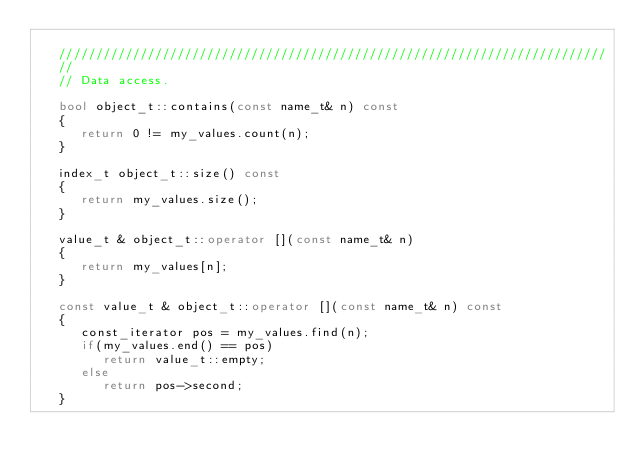<code> <loc_0><loc_0><loc_500><loc_500><_C++_>
   //////////////////////////////////////////////////////////////////////////
   //
   // Data access.

   bool object_t::contains(const name_t& n) const
   {
      return 0 != my_values.count(n);
   }

   index_t object_t::size() const
   {
      return my_values.size();
   }

   value_t & object_t::operator [](const name_t& n)
   {
      return my_values[n];
   }

   const value_t & object_t::operator [](const name_t& n) const
   {
      const_iterator pos = my_values.find(n);
      if(my_values.end() == pos)
         return value_t::empty;
      else
         return pos->second;
   }
</code> 